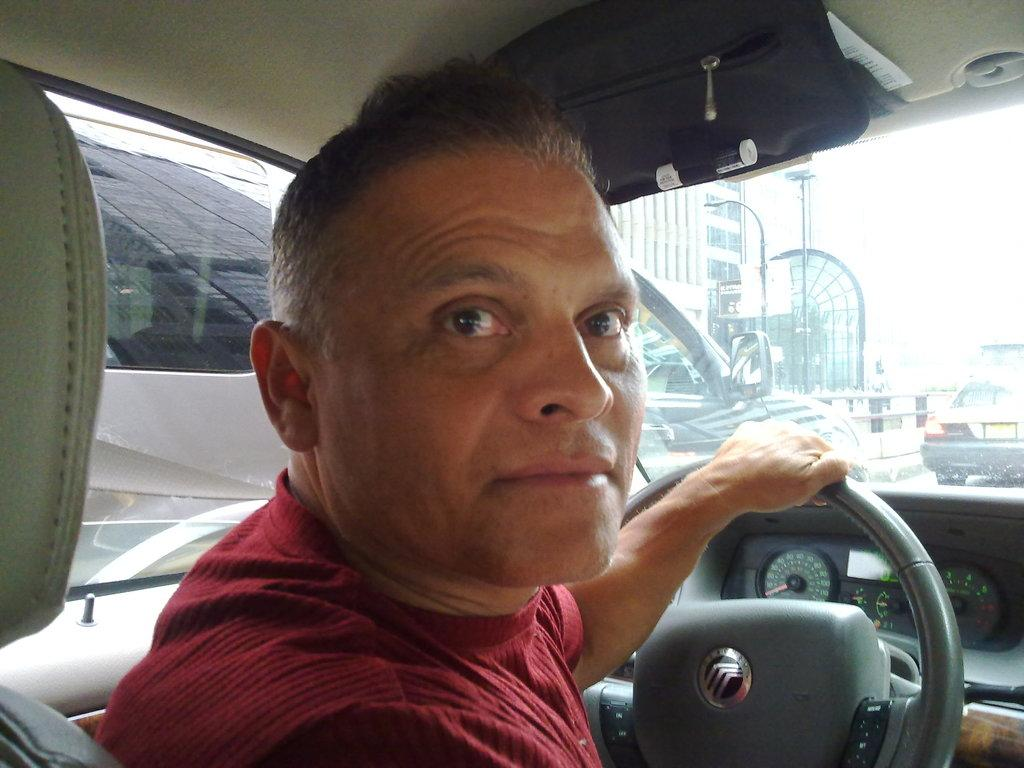What is the setting of the image? The image is an inside view of a car. Who is present in the car? There is a man in the car. What is the man wearing? The man is wearing a red dress. What is the man doing in the car? The man is holding a steering wheel. How many other cars can be seen from the car? There are two more cars visible outside the car. What else can be seen outside the car? There is a building visible outside the car. What type of prison can be seen in the image? There is no prison present in the image; it is an inside view of a car. What kind of growth is visible on the building outside the car? There is no growth visible on the building outside the car; only the building itself can be seen. 